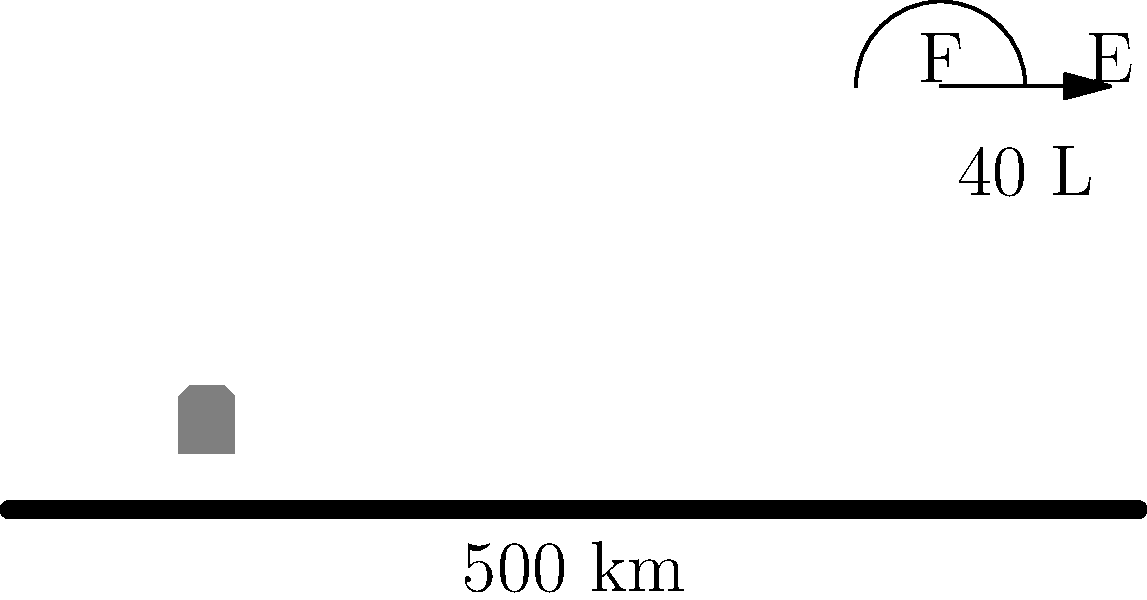You've just finished a long haul in your old pickup truck. The odometer shows you've driven 500 km, and you've burned through 40 L of diesel. What's the fuel efficiency of your truck in km/L? To calculate fuel efficiency, we need to determine how many kilometers the truck can travel per liter of fuel. Here's how we do it:

1) We have two pieces of information:
   - Distance traveled: 500 km
   - Fuel consumed: 40 L

2) The formula for fuel efficiency (in km/L) is:
   $$ \text{Fuel Efficiency} = \frac{\text{Distance Traveled}}{\text{Fuel Consumed}} $$

3) Plugging in our values:
   $$ \text{Fuel Efficiency} = \frac{500 \text{ km}}{40 \text{ L}} $$

4) Perform the division:
   $$ \text{Fuel Efficiency} = 12.5 \text{ km/L} $$

Therefore, the fuel efficiency of the truck is 12.5 km/L.
Answer: 12.5 km/L 